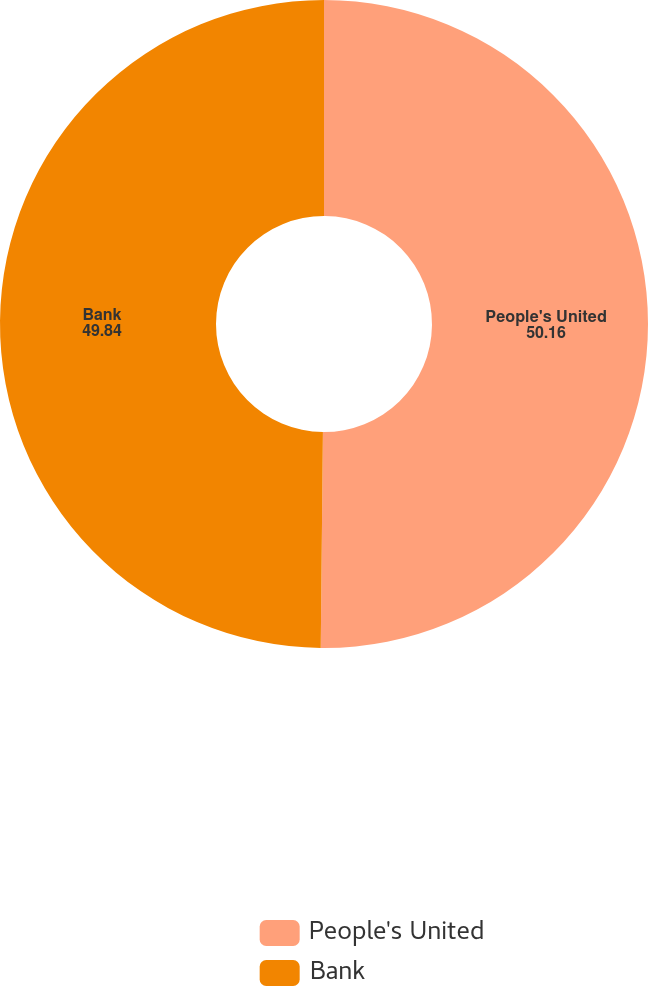Convert chart. <chart><loc_0><loc_0><loc_500><loc_500><pie_chart><fcel>People's United<fcel>Bank<nl><fcel>50.16%<fcel>49.84%<nl></chart> 